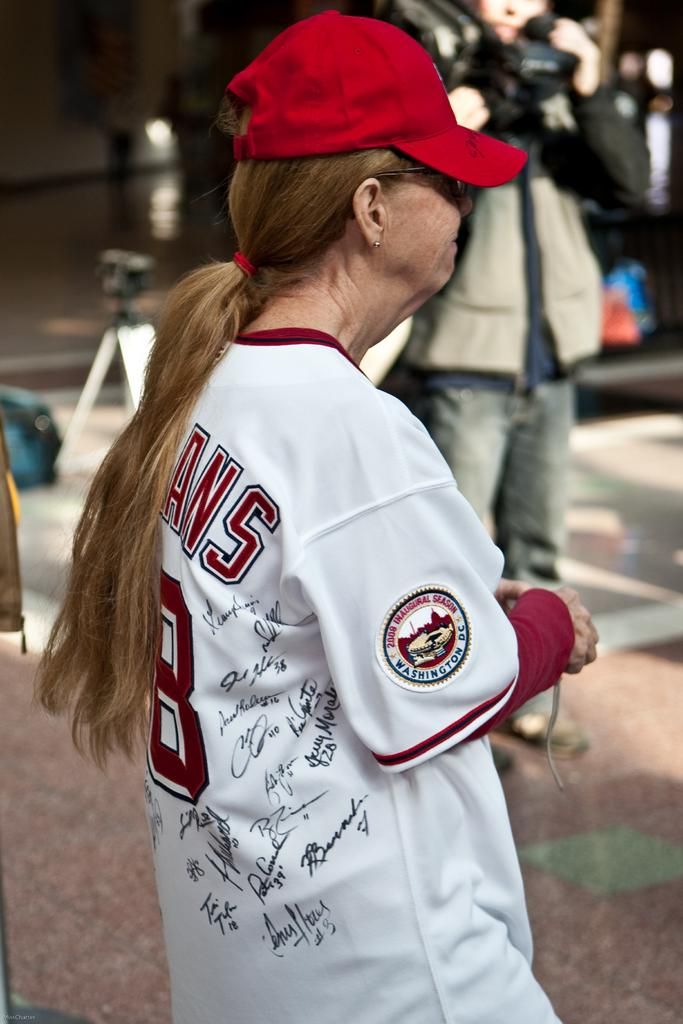<image>
Render a clear and concise summary of the photo. A woman's baseball uniform sports a patch commemorating the 2008 Inaugural Season. 